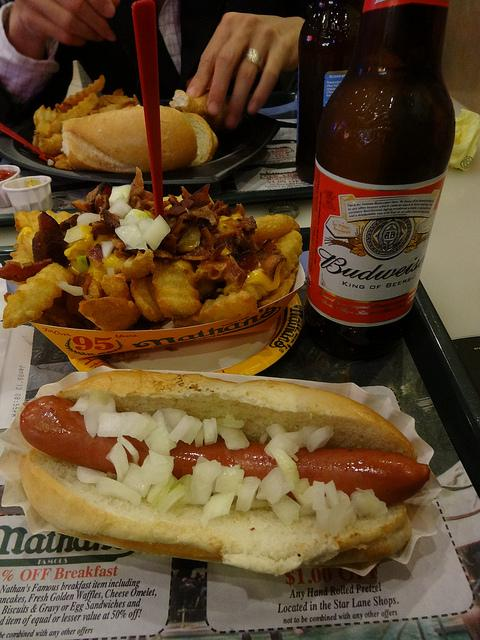Consuming which one of these items will make it dangerous to drive? Please explain your reasoning. in bottle. There is beer in the bottle. you should not drink and drive. 